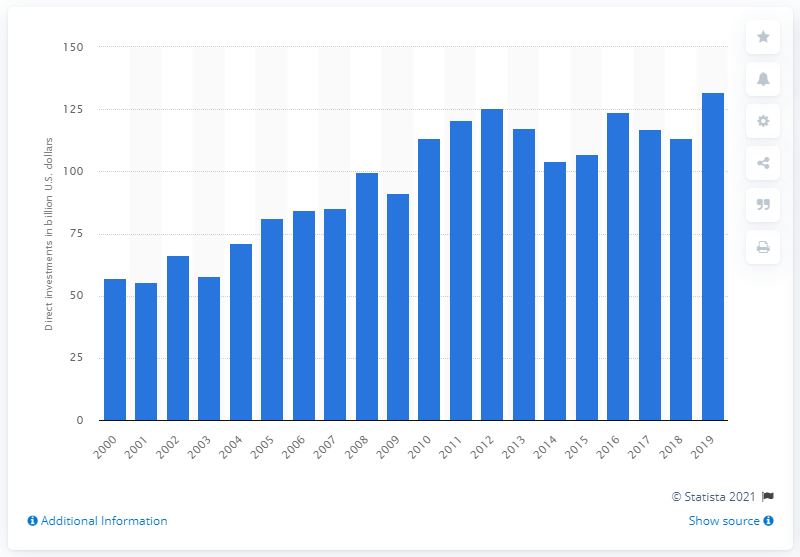Give some essential details in this illustration. In 2019, a total of 131.79 dollars were invested in Japan. 